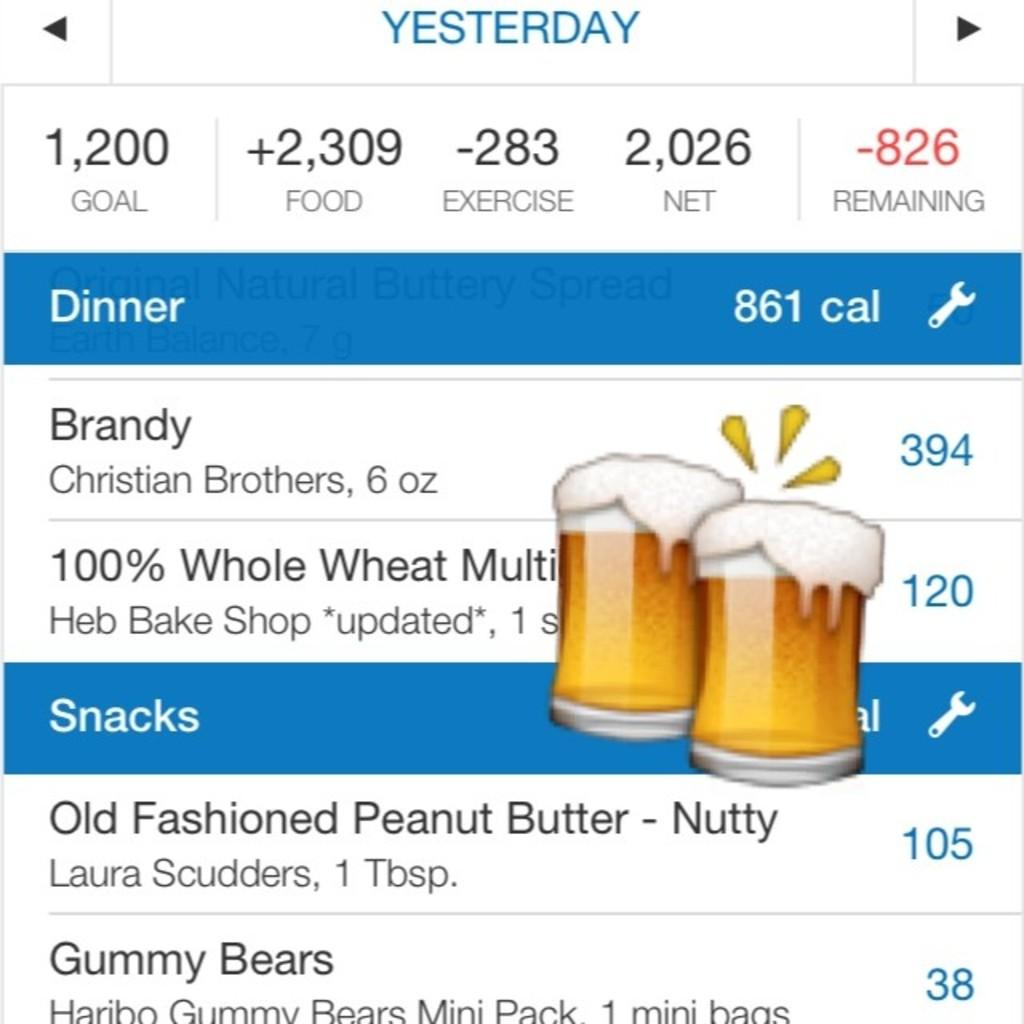<image>
Offer a succinct explanation of the picture presented. A food journal showing they had Brandy and Gummy Bears among other foods throughout their day. 